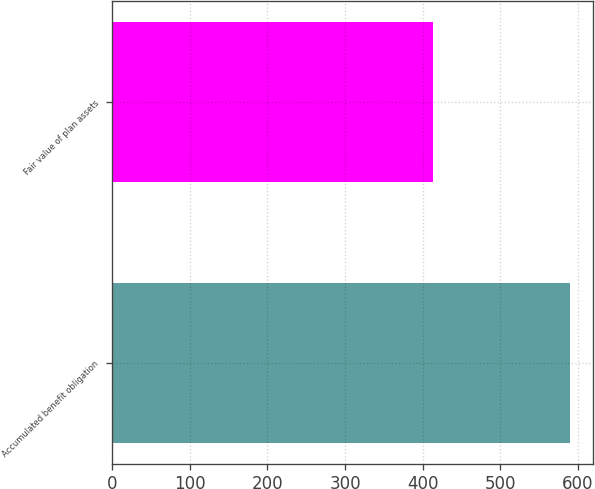Convert chart to OTSL. <chart><loc_0><loc_0><loc_500><loc_500><bar_chart><fcel>Accumulated benefit obligation<fcel>Fair value of plan assets<nl><fcel>590<fcel>414<nl></chart> 